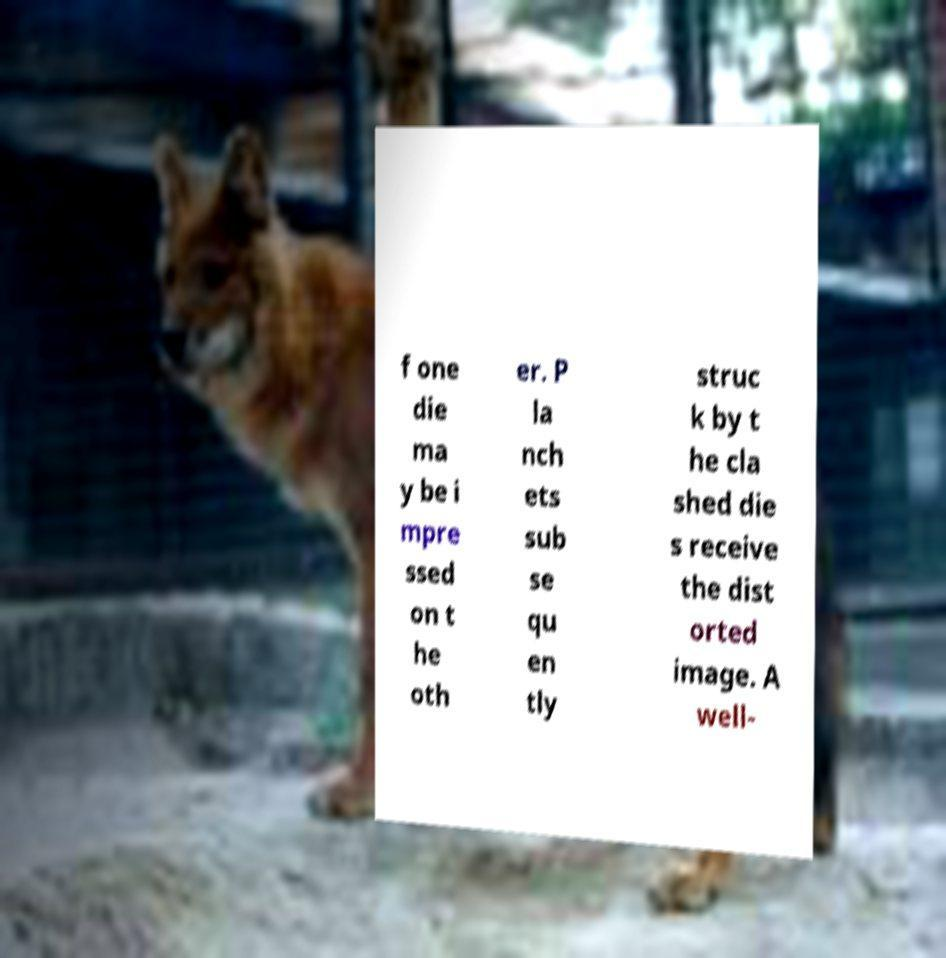Could you extract and type out the text from this image? f one die ma y be i mpre ssed on t he oth er. P la nch ets sub se qu en tly struc k by t he cla shed die s receive the dist orted image. A well- 